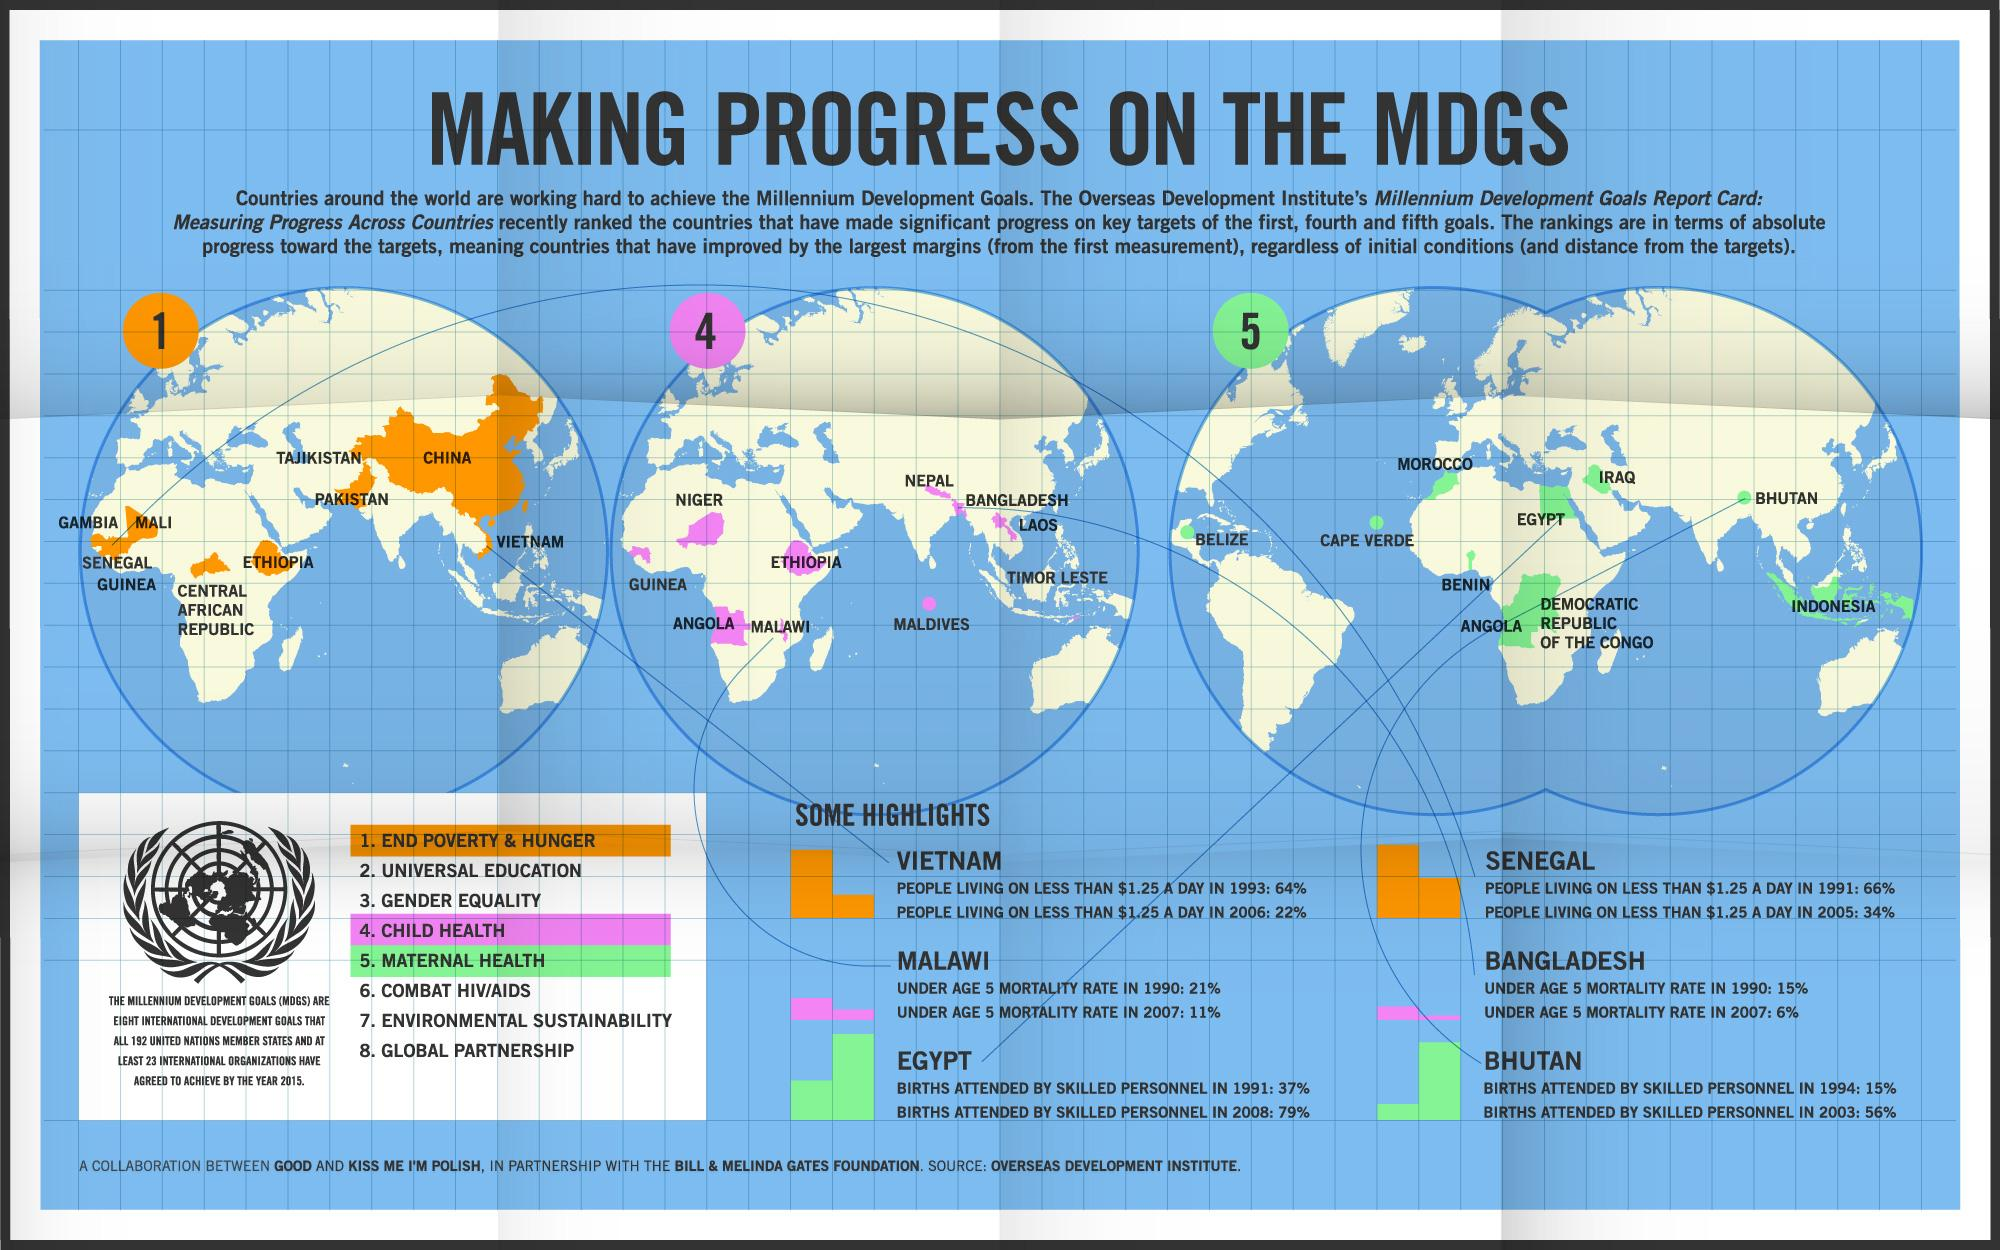Mention a couple of crucial points in this snapshot. Nineteen twenty-two United Nations member states have pledged to achieve the Millennium Development Goals by the year 2015. In 1991, approximately 37% of births in Egypt were attended by skilled personnel. In 1990, the mortality rate of children under the age of five in Bangladesh was 15%. The primary goal of MDGS is to eradicate poverty and hunger. By the year 2015, Bhutan aims to achieve progress in maternal health as part of the Millennium Development Goals (MDGs). 